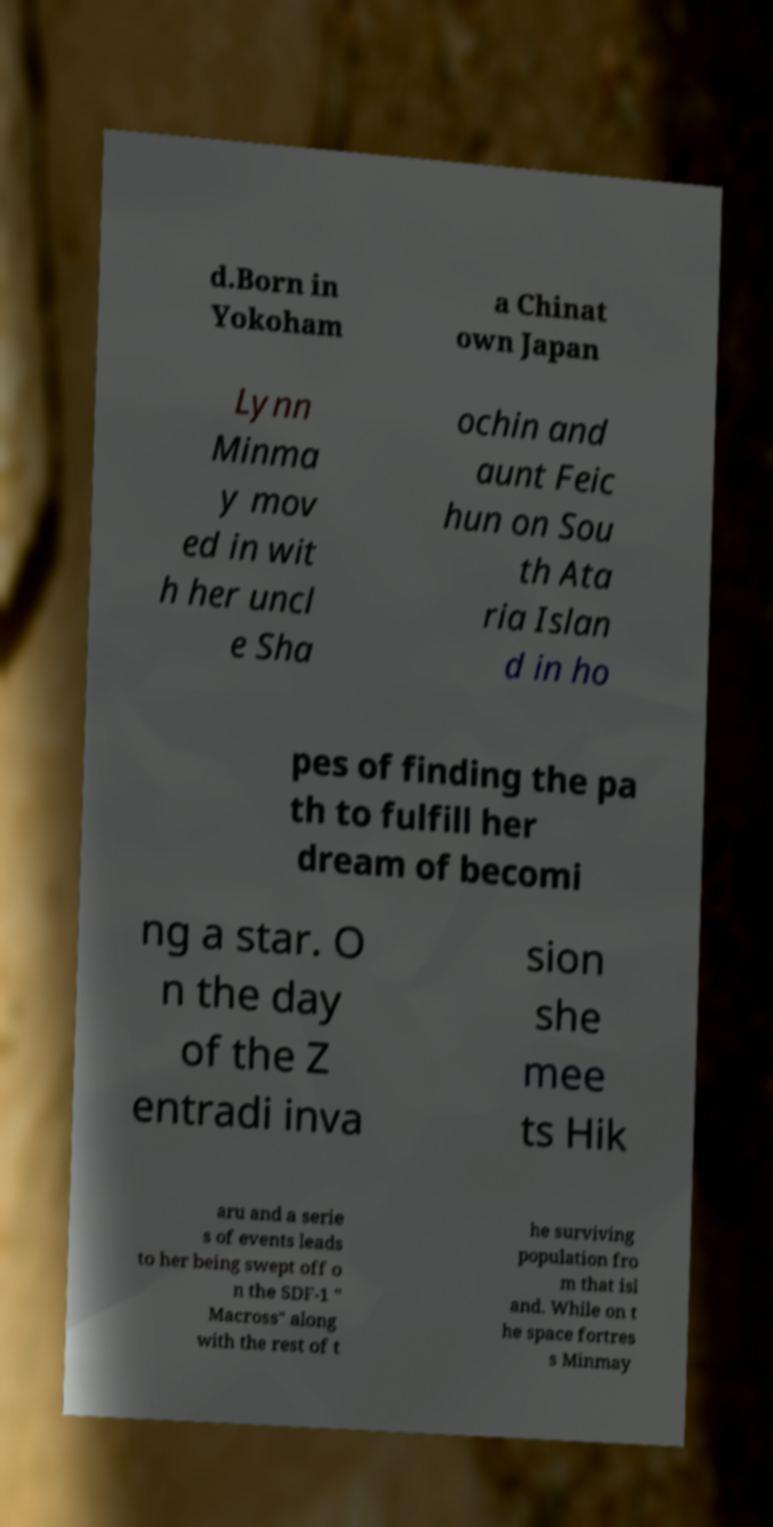Please identify and transcribe the text found in this image. d.Born in Yokoham a Chinat own Japan Lynn Minma y mov ed in wit h her uncl e Sha ochin and aunt Feic hun on Sou th Ata ria Islan d in ho pes of finding the pa th to fulfill her dream of becomi ng a star. O n the day of the Z entradi inva sion she mee ts Hik aru and a serie s of events leads to her being swept off o n the SDF-1 " Macross" along with the rest of t he surviving population fro m that isl and. While on t he space fortres s Minmay 